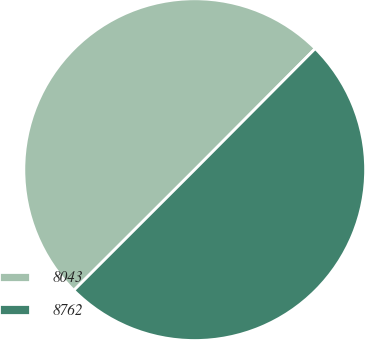Convert chart. <chart><loc_0><loc_0><loc_500><loc_500><pie_chart><fcel>8043<fcel>8762<nl><fcel>49.95%<fcel>50.05%<nl></chart> 